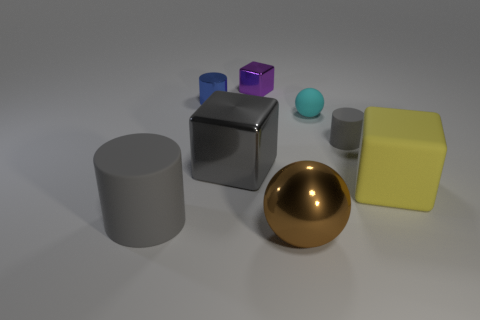Subtract all yellow balls. How many gray cylinders are left? 2 Subtract all big yellow rubber cubes. How many cubes are left? 2 Add 1 large gray shiny objects. How many objects exist? 9 Subtract 1 cylinders. How many cylinders are left? 2 Subtract all cyan balls. How many balls are left? 1 Subtract all cylinders. How many objects are left? 5 Subtract all green cylinders. Subtract all red cubes. How many cylinders are left? 3 Subtract all big gray rubber things. Subtract all big shiny things. How many objects are left? 5 Add 7 large balls. How many large balls are left? 8 Add 3 large blocks. How many large blocks exist? 5 